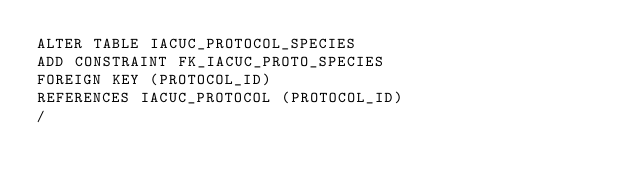Convert code to text. <code><loc_0><loc_0><loc_500><loc_500><_SQL_>ALTER TABLE IACUC_PROTOCOL_SPECIES 
ADD CONSTRAINT FK_IACUC_PROTO_SPECIES 
FOREIGN KEY (PROTOCOL_ID) 
REFERENCES IACUC_PROTOCOL (PROTOCOL_ID)
/

</code> 